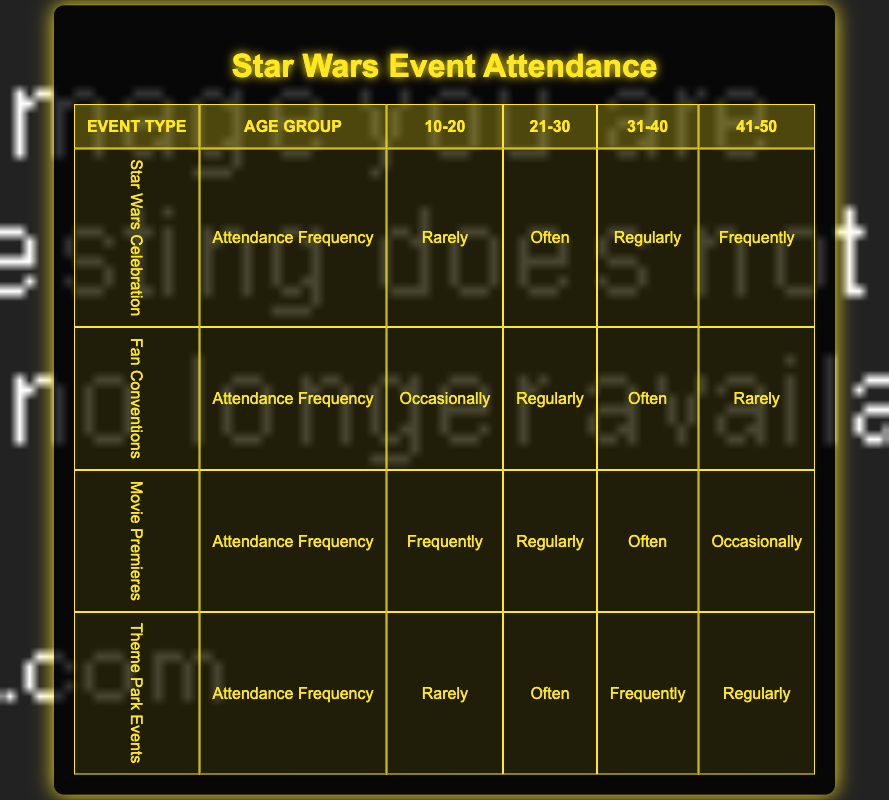What is the attendance frequency of the 31-40 age group for Movie Premieres? From the table, under the column for the age group 31-40 and the event type Movie Premieres, the attendance frequency listed is "Often."
Answer: Often How many event types have an attendance frequency of "Frequently" for the 10-20 age group? In the table, only the Movie Premieres event type has an attendance frequency of "Frequently" for the 10-20 age group. Therefore, there is 1 such event type.
Answer: 1 Is it true that fans aged 41-50 attend Theme Park Events more frequently than Movie Premieres? By comparing both event types, for Theme Park Events the frequency is "Regularly," and for Movie Premieres, it is "Occasionally," confirming that fans aged 41-50 attend Theme Park Events more frequently.
Answer: Yes What is the total number of event types where fans aged 21-30 attend "Regularly"? Looking at the 21-30 age group, the event types that have a "Regularly" attendance frequency are Star Wars Celebration and Movie Premieres. Thus, there are 2 event types.
Answer: 2 For the 31-40 age group, what is the difference in attendance frequency between Fan Conventions and Theme Park Events? The attendance frequency for Fan Conventions is "Often," while for Theme Park Events, it is "Frequently." "Frequently" is a higher frequency than "Often," resulting in a difference where Theme Park Events have a greater frequency of attendance.
Answer: Theme Park Events have a greater frequency What is the average attendance frequency for the 41-50 age group across all event types? The attendance frequencies for 41-50 are: Star Wars Celebration (Frequently), Fan Conventions (Rarely), Movie Premieres (Occasionally), and Theme Park Events (Regularly). Assigning values: Frequently (4), Rarely (1), Occasionally (2), Regularly (3). The sum is 4 + 1 + 2 + 3 = 10, divided by the 4 event types gives an average of 10/4 = 2.5. This averages to between Occasionally and Regularly.
Answer: Average is between Occasionally and Regularly How many fans aged 10-20 attend Star Wars Celebration? For the 10-20 age group, there is one entry for Star Wars Celebration, which indicates they attend "Rarely."
Answer: Rarely Which age group has the highest attendance frequency for Star Wars Celebration? Reviewing the age groups for Star Wars Celebration: 10-20 (Rarely), 21-30 (Often), 31-40 (Regularly), 41-50 (Frequently). The highest frequency is from the 41-50 age group with "Frequently."
Answer: 41-50 age group with "Frequently." What is the attendance frequency for fans aged 21-30 attending Movie Premieres? Looking at the table, for the age group 21-30 attending Movie Premieres, the listed attendance frequency is "Regularly."
Answer: Regularly 